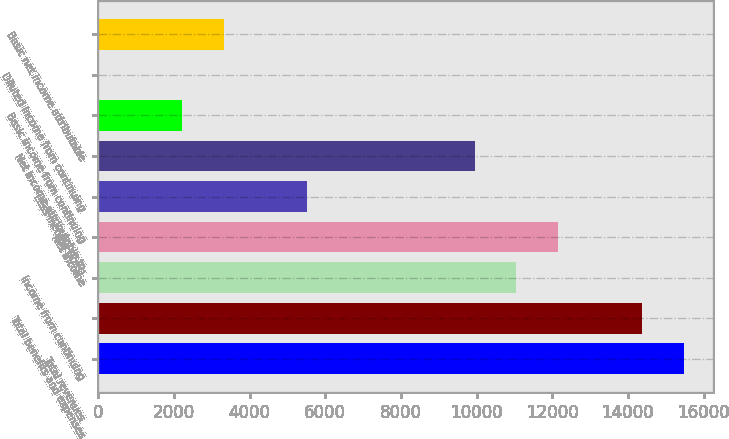<chart> <loc_0><loc_0><loc_500><loc_500><bar_chart><fcel>Total revenues<fcel>Total benefits and expenses<fcel>Income from continuing<fcel>Net income<fcel>Less Income (loss)<fcel>Net income attributable to<fcel>Basic income from continuing<fcel>Diluted income from continuing<fcel>Basic net income attributable<nl><fcel>15474.9<fcel>14369.7<fcel>11054<fcel>12159.2<fcel>5527.85<fcel>9948.77<fcel>2212.16<fcel>1.7<fcel>3317.39<nl></chart> 